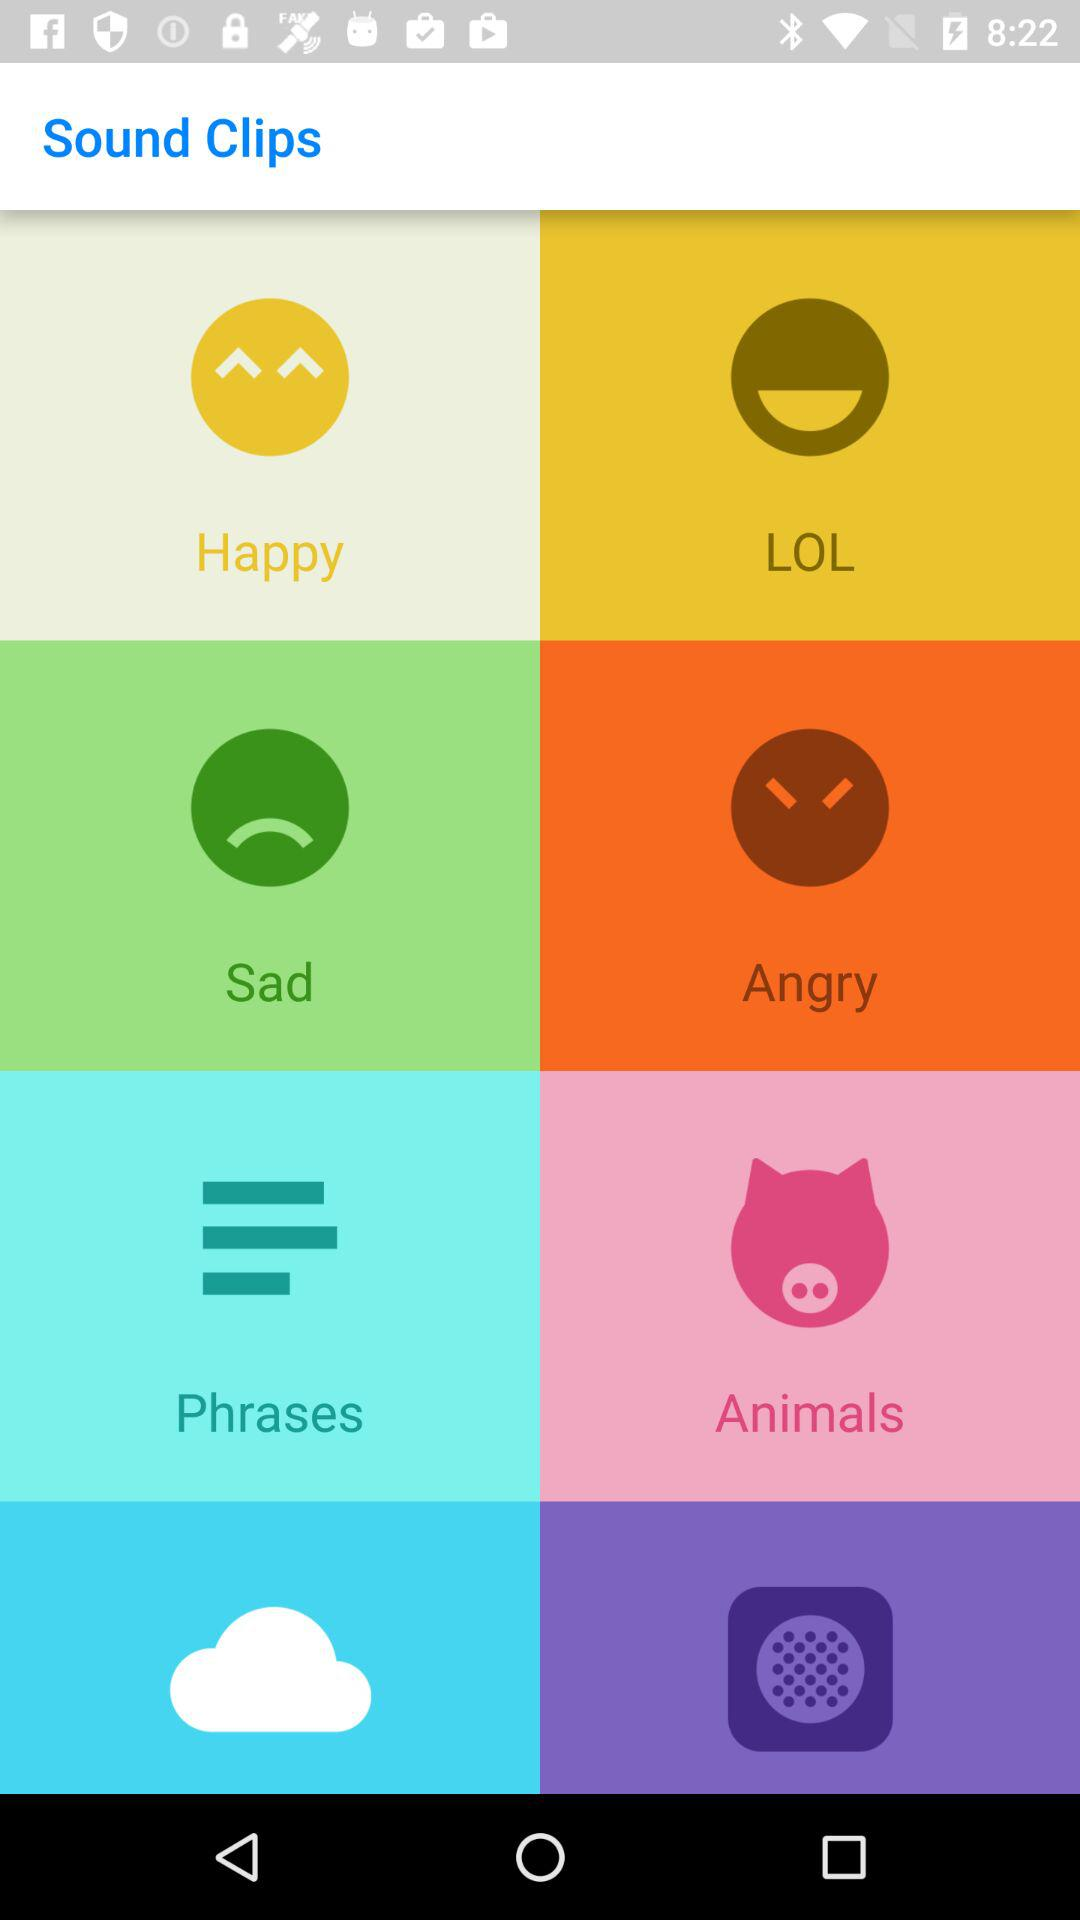What is the name of the application? The name of the application is "Sound Clips". 